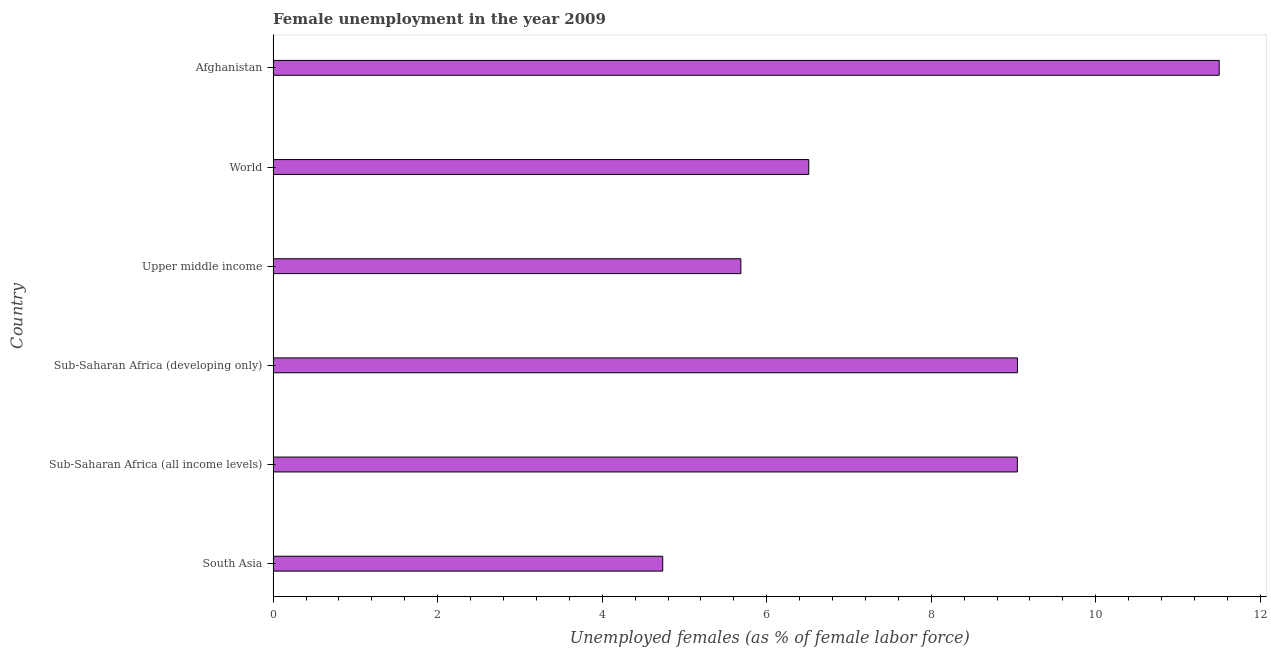Does the graph contain any zero values?
Ensure brevity in your answer.  No. Does the graph contain grids?
Offer a terse response. No. What is the title of the graph?
Ensure brevity in your answer.  Female unemployment in the year 2009. What is the label or title of the X-axis?
Ensure brevity in your answer.  Unemployed females (as % of female labor force). What is the unemployed females population in Sub-Saharan Africa (all income levels)?
Offer a very short reply. 9.05. Across all countries, what is the maximum unemployed females population?
Offer a very short reply. 11.5. Across all countries, what is the minimum unemployed females population?
Offer a terse response. 4.74. In which country was the unemployed females population maximum?
Offer a very short reply. Afghanistan. What is the sum of the unemployed females population?
Provide a succinct answer. 46.53. What is the difference between the unemployed females population in Afghanistan and Sub-Saharan Africa (all income levels)?
Provide a short and direct response. 2.45. What is the average unemployed females population per country?
Make the answer very short. 7.75. What is the median unemployed females population?
Your response must be concise. 7.78. In how many countries, is the unemployed females population greater than 11.6 %?
Provide a succinct answer. 0. What is the ratio of the unemployed females population in Sub-Saharan Africa (all income levels) to that in World?
Offer a terse response. 1.39. Is the difference between the unemployed females population in South Asia and Upper middle income greater than the difference between any two countries?
Offer a very short reply. No. What is the difference between the highest and the second highest unemployed females population?
Your response must be concise. 2.45. What is the difference between the highest and the lowest unemployed females population?
Provide a succinct answer. 6.76. How many bars are there?
Your response must be concise. 6. Are all the bars in the graph horizontal?
Your answer should be compact. Yes. How many countries are there in the graph?
Your answer should be very brief. 6. What is the difference between two consecutive major ticks on the X-axis?
Ensure brevity in your answer.  2. What is the Unemployed females (as % of female labor force) of South Asia?
Offer a terse response. 4.74. What is the Unemployed females (as % of female labor force) of Sub-Saharan Africa (all income levels)?
Give a very brief answer. 9.05. What is the Unemployed females (as % of female labor force) in Sub-Saharan Africa (developing only)?
Provide a short and direct response. 9.05. What is the Unemployed females (as % of female labor force) in Upper middle income?
Your response must be concise. 5.69. What is the Unemployed females (as % of female labor force) in World?
Keep it short and to the point. 6.51. What is the Unemployed females (as % of female labor force) in Afghanistan?
Offer a terse response. 11.5. What is the difference between the Unemployed females (as % of female labor force) in South Asia and Sub-Saharan Africa (all income levels)?
Offer a terse response. -4.31. What is the difference between the Unemployed females (as % of female labor force) in South Asia and Sub-Saharan Africa (developing only)?
Offer a very short reply. -4.31. What is the difference between the Unemployed females (as % of female labor force) in South Asia and Upper middle income?
Provide a short and direct response. -0.95. What is the difference between the Unemployed females (as % of female labor force) in South Asia and World?
Offer a very short reply. -1.78. What is the difference between the Unemployed females (as % of female labor force) in South Asia and Afghanistan?
Keep it short and to the point. -6.76. What is the difference between the Unemployed females (as % of female labor force) in Sub-Saharan Africa (all income levels) and Sub-Saharan Africa (developing only)?
Offer a terse response. -0. What is the difference between the Unemployed females (as % of female labor force) in Sub-Saharan Africa (all income levels) and Upper middle income?
Make the answer very short. 3.36. What is the difference between the Unemployed females (as % of female labor force) in Sub-Saharan Africa (all income levels) and World?
Give a very brief answer. 2.54. What is the difference between the Unemployed females (as % of female labor force) in Sub-Saharan Africa (all income levels) and Afghanistan?
Make the answer very short. -2.45. What is the difference between the Unemployed females (as % of female labor force) in Sub-Saharan Africa (developing only) and Upper middle income?
Your answer should be compact. 3.36. What is the difference between the Unemployed females (as % of female labor force) in Sub-Saharan Africa (developing only) and World?
Keep it short and to the point. 2.54. What is the difference between the Unemployed females (as % of female labor force) in Sub-Saharan Africa (developing only) and Afghanistan?
Keep it short and to the point. -2.45. What is the difference between the Unemployed females (as % of female labor force) in Upper middle income and World?
Your answer should be compact. -0.83. What is the difference between the Unemployed females (as % of female labor force) in Upper middle income and Afghanistan?
Offer a very short reply. -5.81. What is the difference between the Unemployed females (as % of female labor force) in World and Afghanistan?
Make the answer very short. -4.99. What is the ratio of the Unemployed females (as % of female labor force) in South Asia to that in Sub-Saharan Africa (all income levels)?
Provide a short and direct response. 0.52. What is the ratio of the Unemployed females (as % of female labor force) in South Asia to that in Sub-Saharan Africa (developing only)?
Make the answer very short. 0.52. What is the ratio of the Unemployed females (as % of female labor force) in South Asia to that in Upper middle income?
Ensure brevity in your answer.  0.83. What is the ratio of the Unemployed females (as % of female labor force) in South Asia to that in World?
Offer a terse response. 0.73. What is the ratio of the Unemployed females (as % of female labor force) in South Asia to that in Afghanistan?
Provide a succinct answer. 0.41. What is the ratio of the Unemployed females (as % of female labor force) in Sub-Saharan Africa (all income levels) to that in Upper middle income?
Your answer should be compact. 1.59. What is the ratio of the Unemployed females (as % of female labor force) in Sub-Saharan Africa (all income levels) to that in World?
Your answer should be very brief. 1.39. What is the ratio of the Unemployed females (as % of female labor force) in Sub-Saharan Africa (all income levels) to that in Afghanistan?
Make the answer very short. 0.79. What is the ratio of the Unemployed females (as % of female labor force) in Sub-Saharan Africa (developing only) to that in Upper middle income?
Keep it short and to the point. 1.59. What is the ratio of the Unemployed females (as % of female labor force) in Sub-Saharan Africa (developing only) to that in World?
Provide a short and direct response. 1.39. What is the ratio of the Unemployed females (as % of female labor force) in Sub-Saharan Africa (developing only) to that in Afghanistan?
Your answer should be very brief. 0.79. What is the ratio of the Unemployed females (as % of female labor force) in Upper middle income to that in World?
Give a very brief answer. 0.87. What is the ratio of the Unemployed females (as % of female labor force) in Upper middle income to that in Afghanistan?
Your answer should be compact. 0.49. What is the ratio of the Unemployed females (as % of female labor force) in World to that in Afghanistan?
Give a very brief answer. 0.57. 